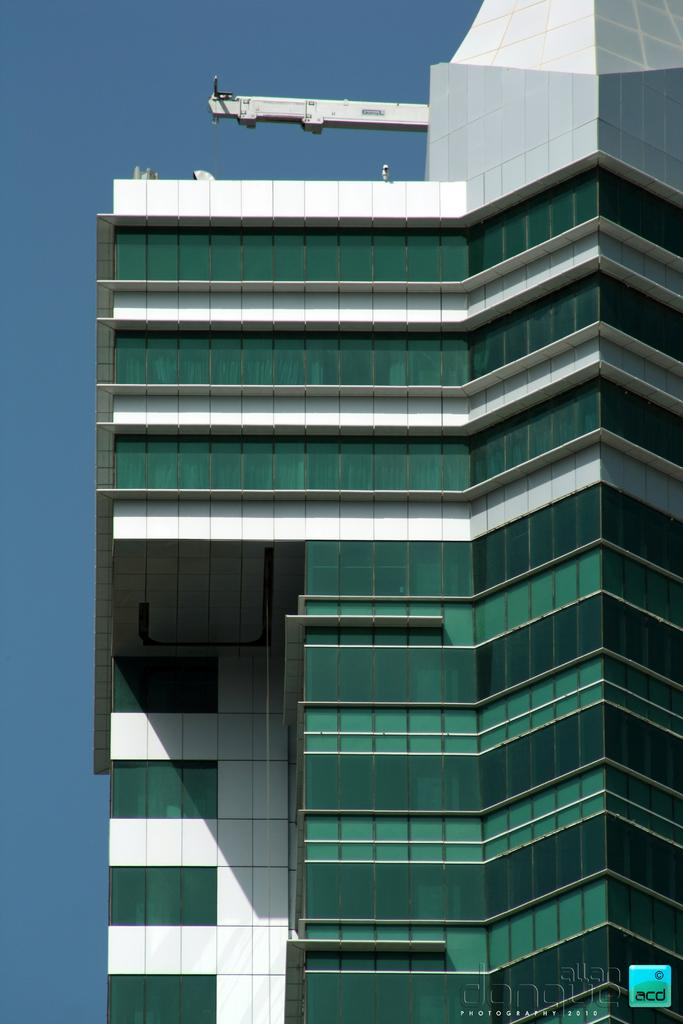What type of structure is present in the image? There is a building in the image. What specific features can be seen on the building? The building has glass elements and pillars. Is there any branding or identification on the building? Yes, there is a logo in the bottom right corner of the image. What can be seen in the background of the image? The sky is visible in the background of the image. What type of pen is being used to write on the glass elements of the building in the image? There is no pen or writing visible on the glass elements of the building in the image. 